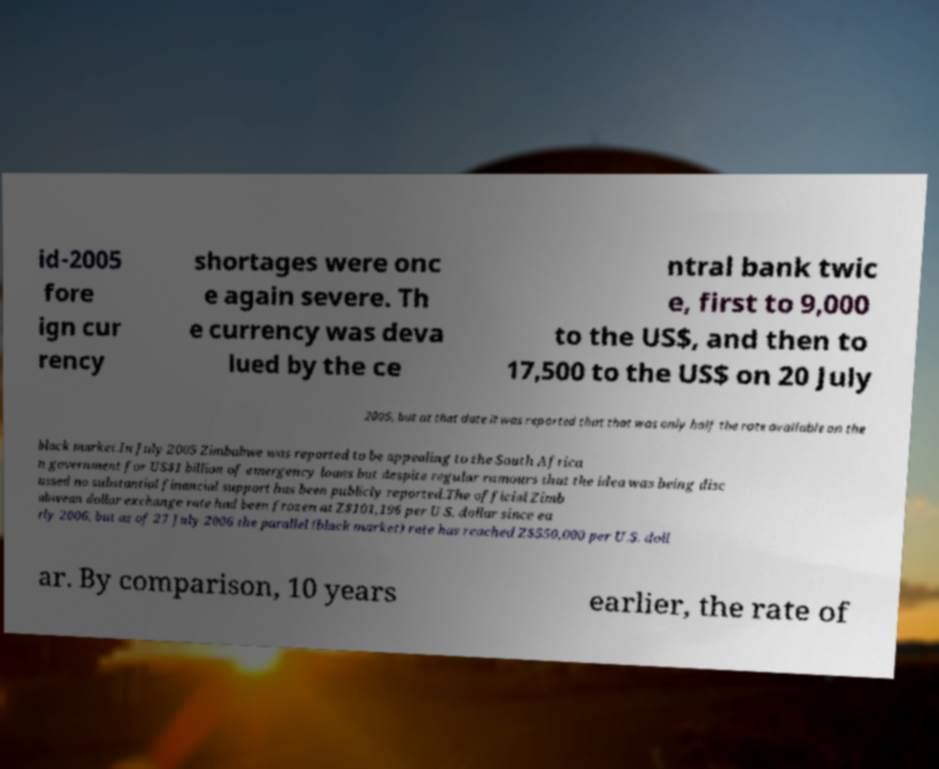Can you accurately transcribe the text from the provided image for me? id-2005 fore ign cur rency shortages were onc e again severe. Th e currency was deva lued by the ce ntral bank twic e, first to 9,000 to the US$, and then to 17,500 to the US$ on 20 July 2005, but at that date it was reported that that was only half the rate available on the black market.In July 2005 Zimbabwe was reported to be appealing to the South Africa n government for US$1 billion of emergency loans but despite regular rumours that the idea was being disc ussed no substantial financial support has been publicly reported.The official Zimb abwean dollar exchange rate had been frozen at Z$101,196 per U.S. dollar since ea rly 2006, but as of 27 July 2006 the parallel (black market) rate has reached Z$550,000 per U.S. doll ar. By comparison, 10 years earlier, the rate of 